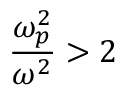<formula> <loc_0><loc_0><loc_500><loc_500>{ \frac { \omega _ { p } ^ { 2 } } { \omega ^ { 2 } } } > 2</formula> 